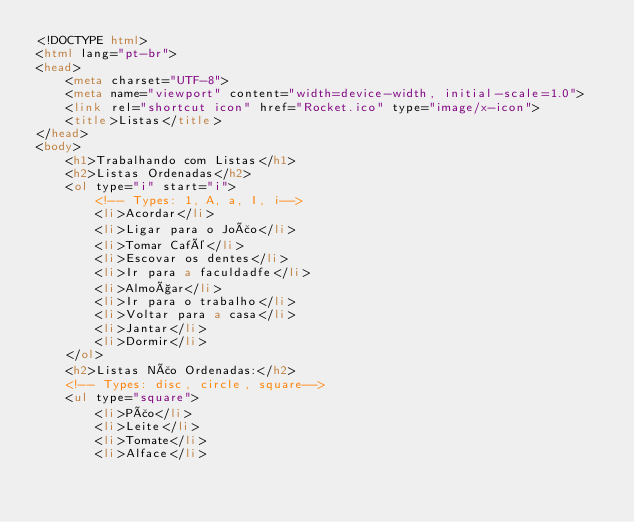Convert code to text. <code><loc_0><loc_0><loc_500><loc_500><_HTML_><!DOCTYPE html>
<html lang="pt-br">
<head>
    <meta charset="UTF-8">
    <meta name="viewport" content="width=device-width, initial-scale=1.0">
    <link rel="shortcut icon" href="Rocket.ico" type="image/x-icon">
    <title>Listas</title>
</head>
<body>
    <h1>Trabalhando com Listas</h1>
    <h2>Listas Ordenadas</h2>
    <ol type="i" start="i">
        <!-- Types: 1, A, a, I, i-->
        <li>Acordar</li>
        <li>Ligar para o João</li>
        <li>Tomar Café</li>
        <li>Escovar os dentes</li>
        <li>Ir para a faculdadfe</li>
        <li>Almoçar</li>
        <li>Ir para o trabalho</li>
        <li>Voltar para a casa</li>
        <li>Jantar</li>
        <li>Dormir</li>
    </ol>
    <h2>Listas Não Ordenadas:</h2>
    <!-- Types: disc, circle, square-->
    <ul type="square">
        <li>Pão</li>
        <li>Leite</li>
        <li>Tomate</li>
        <li>Alface</li></code> 